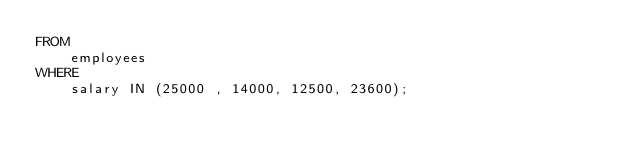Convert code to text. <code><loc_0><loc_0><loc_500><loc_500><_SQL_>FROM
    employees
WHERE
    salary IN (25000 , 14000, 12500, 23600);</code> 